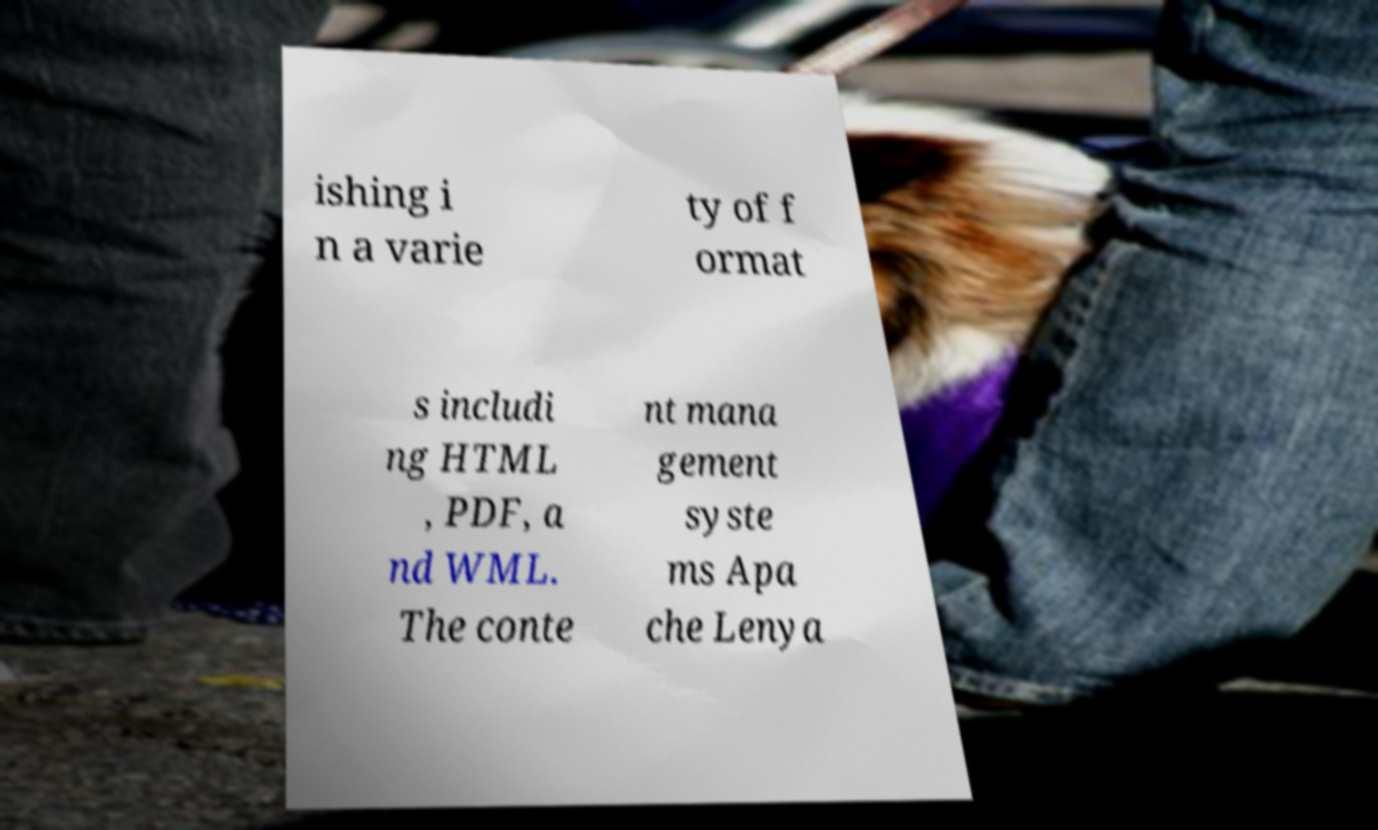Could you assist in decoding the text presented in this image and type it out clearly? ishing i n a varie ty of f ormat s includi ng HTML , PDF, a nd WML. The conte nt mana gement syste ms Apa che Lenya 